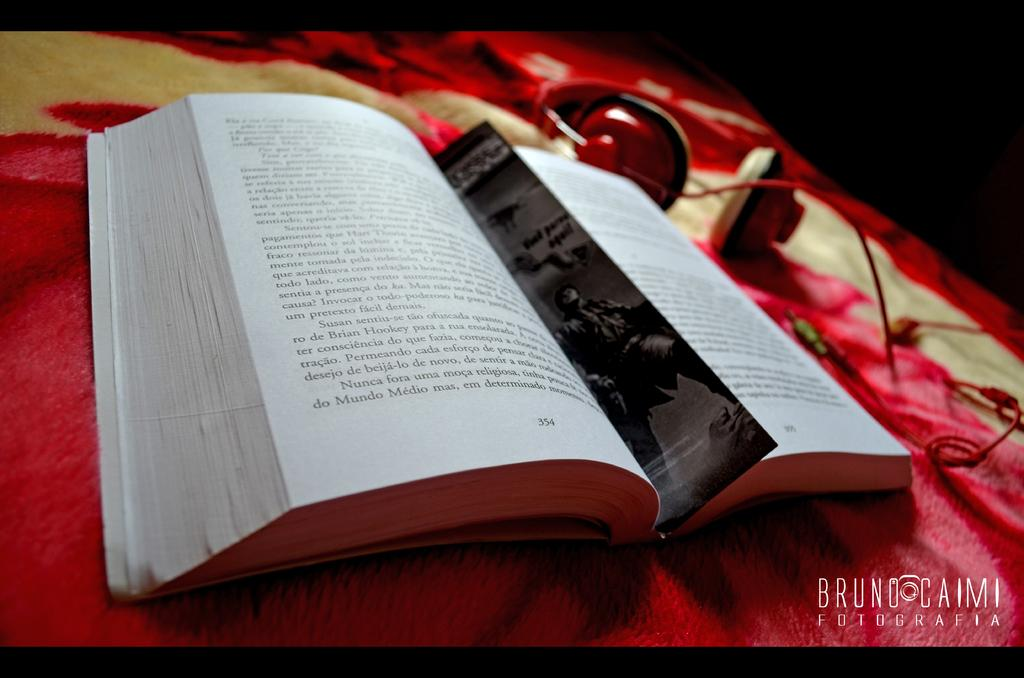<image>
Relay a brief, clear account of the picture shown. Bruno Caimi is written next to a book 